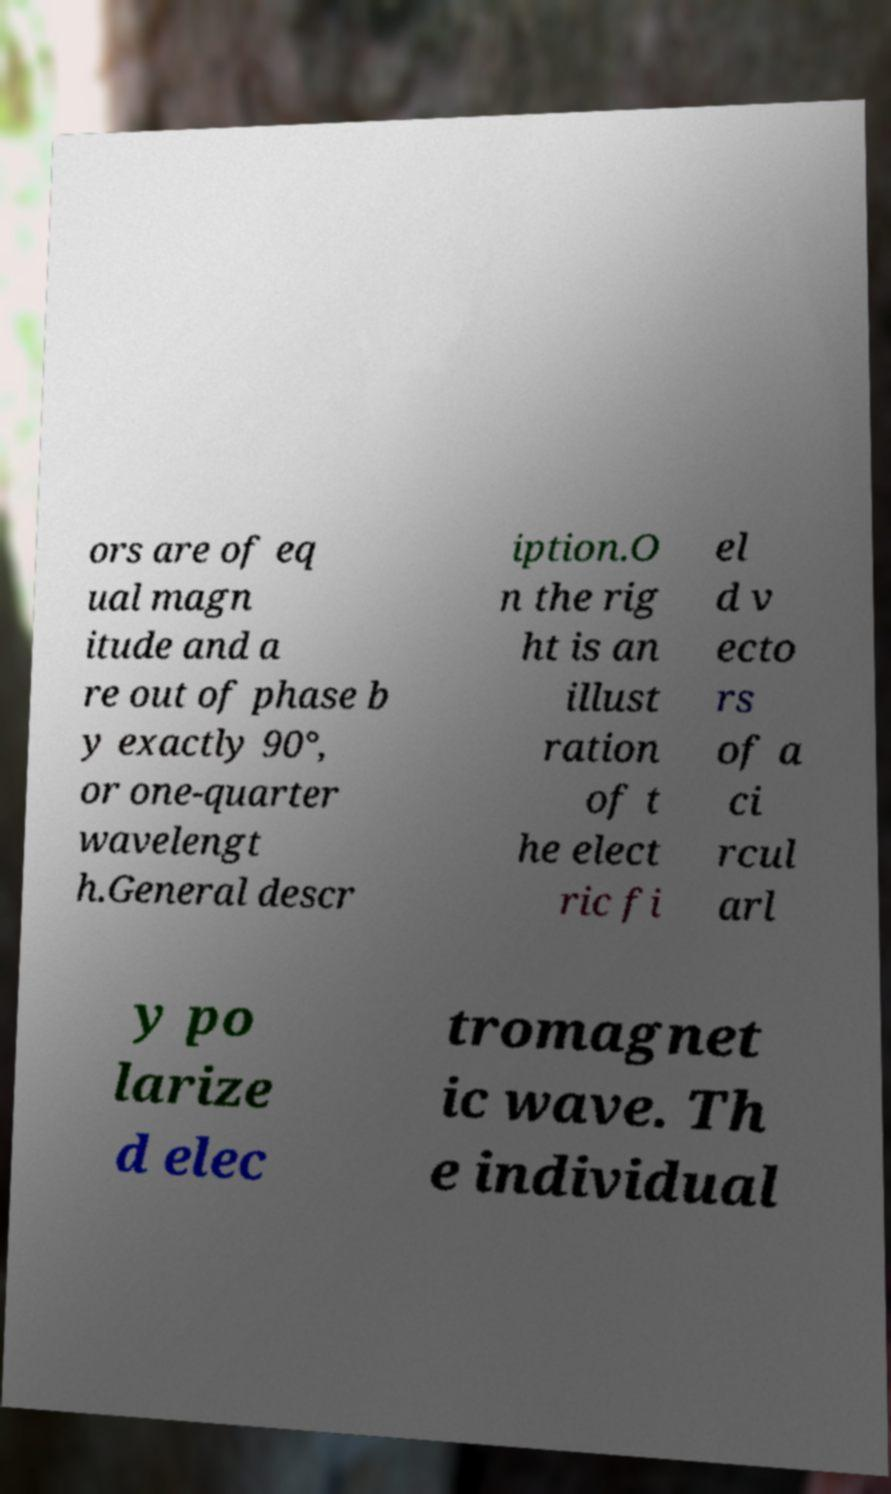Could you assist in decoding the text presented in this image and type it out clearly? ors are of eq ual magn itude and a re out of phase b y exactly 90°, or one-quarter wavelengt h.General descr iption.O n the rig ht is an illust ration of t he elect ric fi el d v ecto rs of a ci rcul arl y po larize d elec tromagnet ic wave. Th e individual 